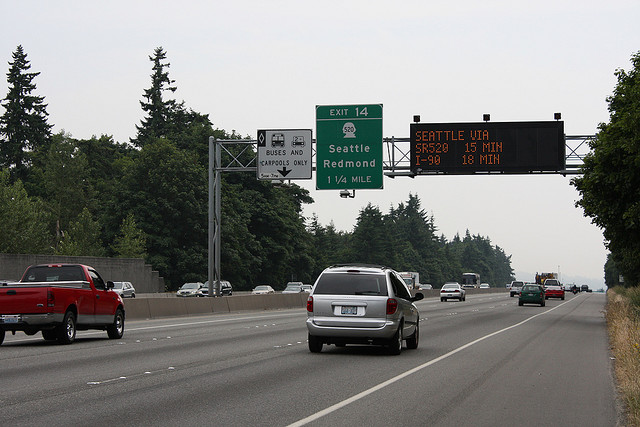<image>How far away is W 130th St? It is unknown how far away is W 130th St. What is the speed limit for the right three lanes? The speed limit for the right three lanes is not shown in the image. However, it could be either 55, 45, or 60. How far away is W 130th St? I don't know how far away W 130th St is. It can be 1 1 4 mile or 30 miles. What is the speed limit for the right three lanes? I don't know the speed limit for the right three lanes. It can be either 55 or unknown. 